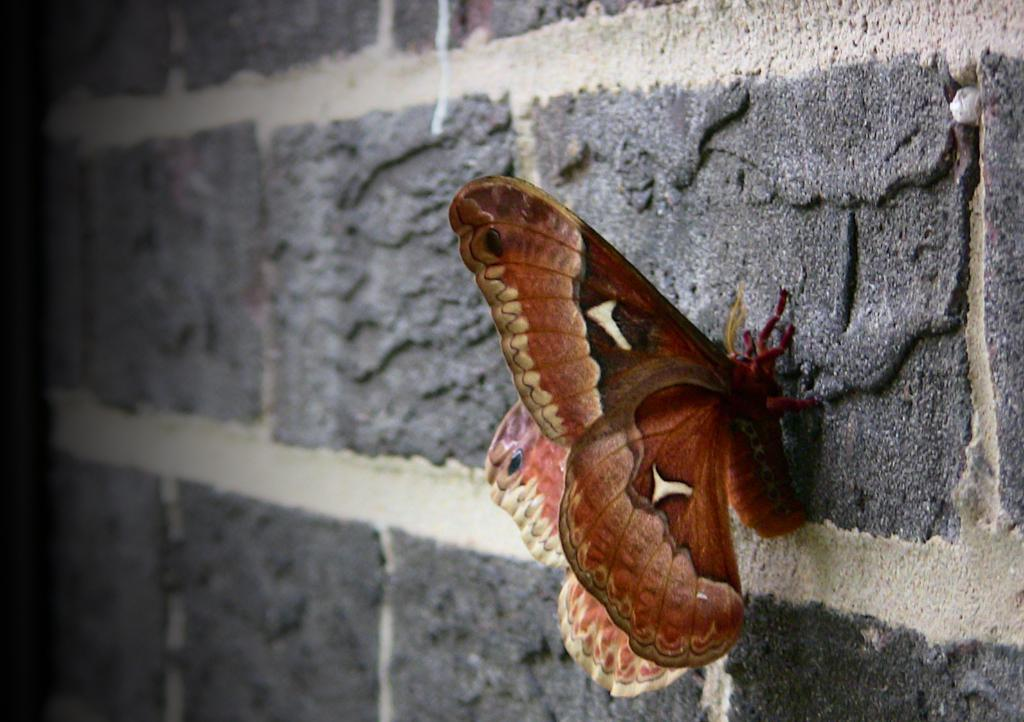What type of creature is present in the image? There is a butterfly in the image. Where is the butterfly located in the image? The butterfly is on the wall. What type of linen is used to make the butterfly's wings in the image? There is no linen present in the image, as butterflies are not made of fabric. 